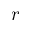<formula> <loc_0><loc_0><loc_500><loc_500>r</formula> 